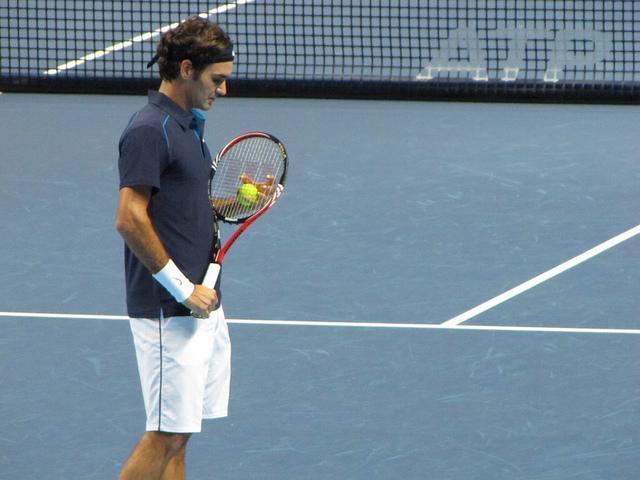What hair accessory is the player wearing to keep his hair out of his face?
Indicate the correct response by choosing from the four available options to answer the question.
Options: Clip, bandana, sweatband, scrunchy. Sweatband. 